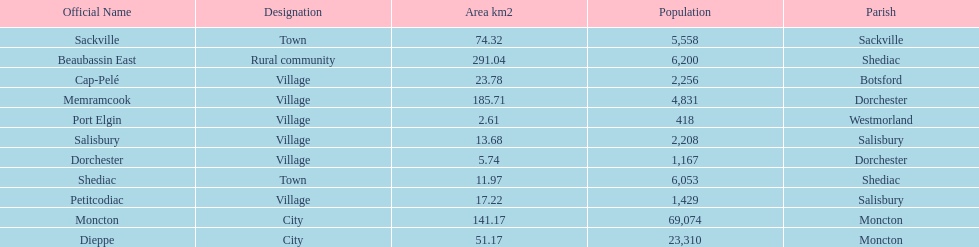How many municipalities have areas that are below 50 square kilometers? 6. I'm looking to parse the entire table for insights. Could you assist me with that? {'header': ['Official Name', 'Designation', 'Area km2', 'Population', 'Parish'], 'rows': [['Sackville', 'Town', '74.32', '5,558', 'Sackville'], ['Beaubassin East', 'Rural community', '291.04', '6,200', 'Shediac'], ['Cap-Pelé', 'Village', '23.78', '2,256', 'Botsford'], ['Memramcook', 'Village', '185.71', '4,831', 'Dorchester'], ['Port Elgin', 'Village', '2.61', '418', 'Westmorland'], ['Salisbury', 'Village', '13.68', '2,208', 'Salisbury'], ['Dorchester', 'Village', '5.74', '1,167', 'Dorchester'], ['Shediac', 'Town', '11.97', '6,053', 'Shediac'], ['Petitcodiac', 'Village', '17.22', '1,429', 'Salisbury'], ['Moncton', 'City', '141.17', '69,074', 'Moncton'], ['Dieppe', 'City', '51.17', '23,310', 'Moncton']]} 